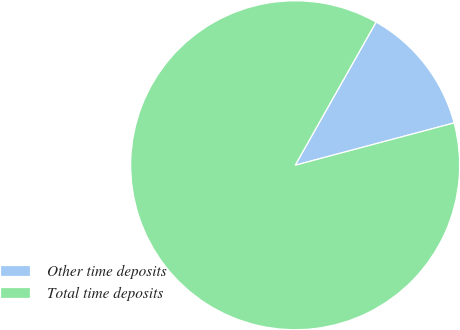Convert chart to OTSL. <chart><loc_0><loc_0><loc_500><loc_500><pie_chart><fcel>Other time deposits<fcel>Total time deposits<nl><fcel>12.67%<fcel>87.33%<nl></chart> 